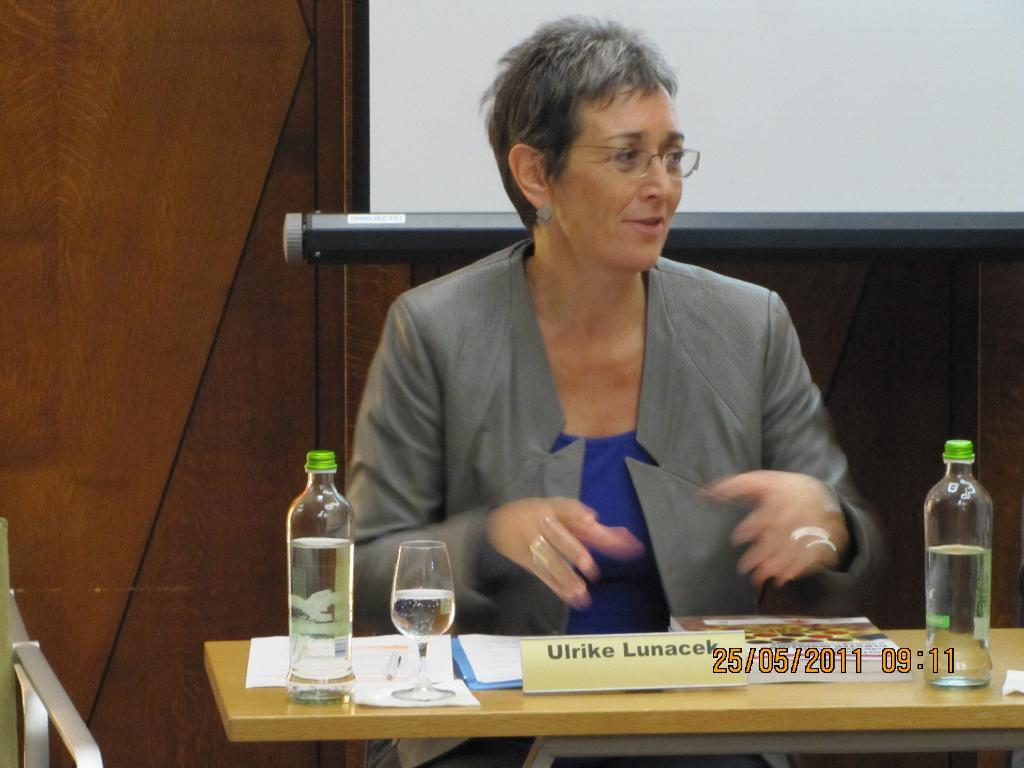<image>
Share a concise interpretation of the image provided. A grey haired lady Ulrike Lunacek, picture taken on 25/05/2011 at 09:11, with specs sitting on a desk with some drinks and a goblet glass, discussing something 